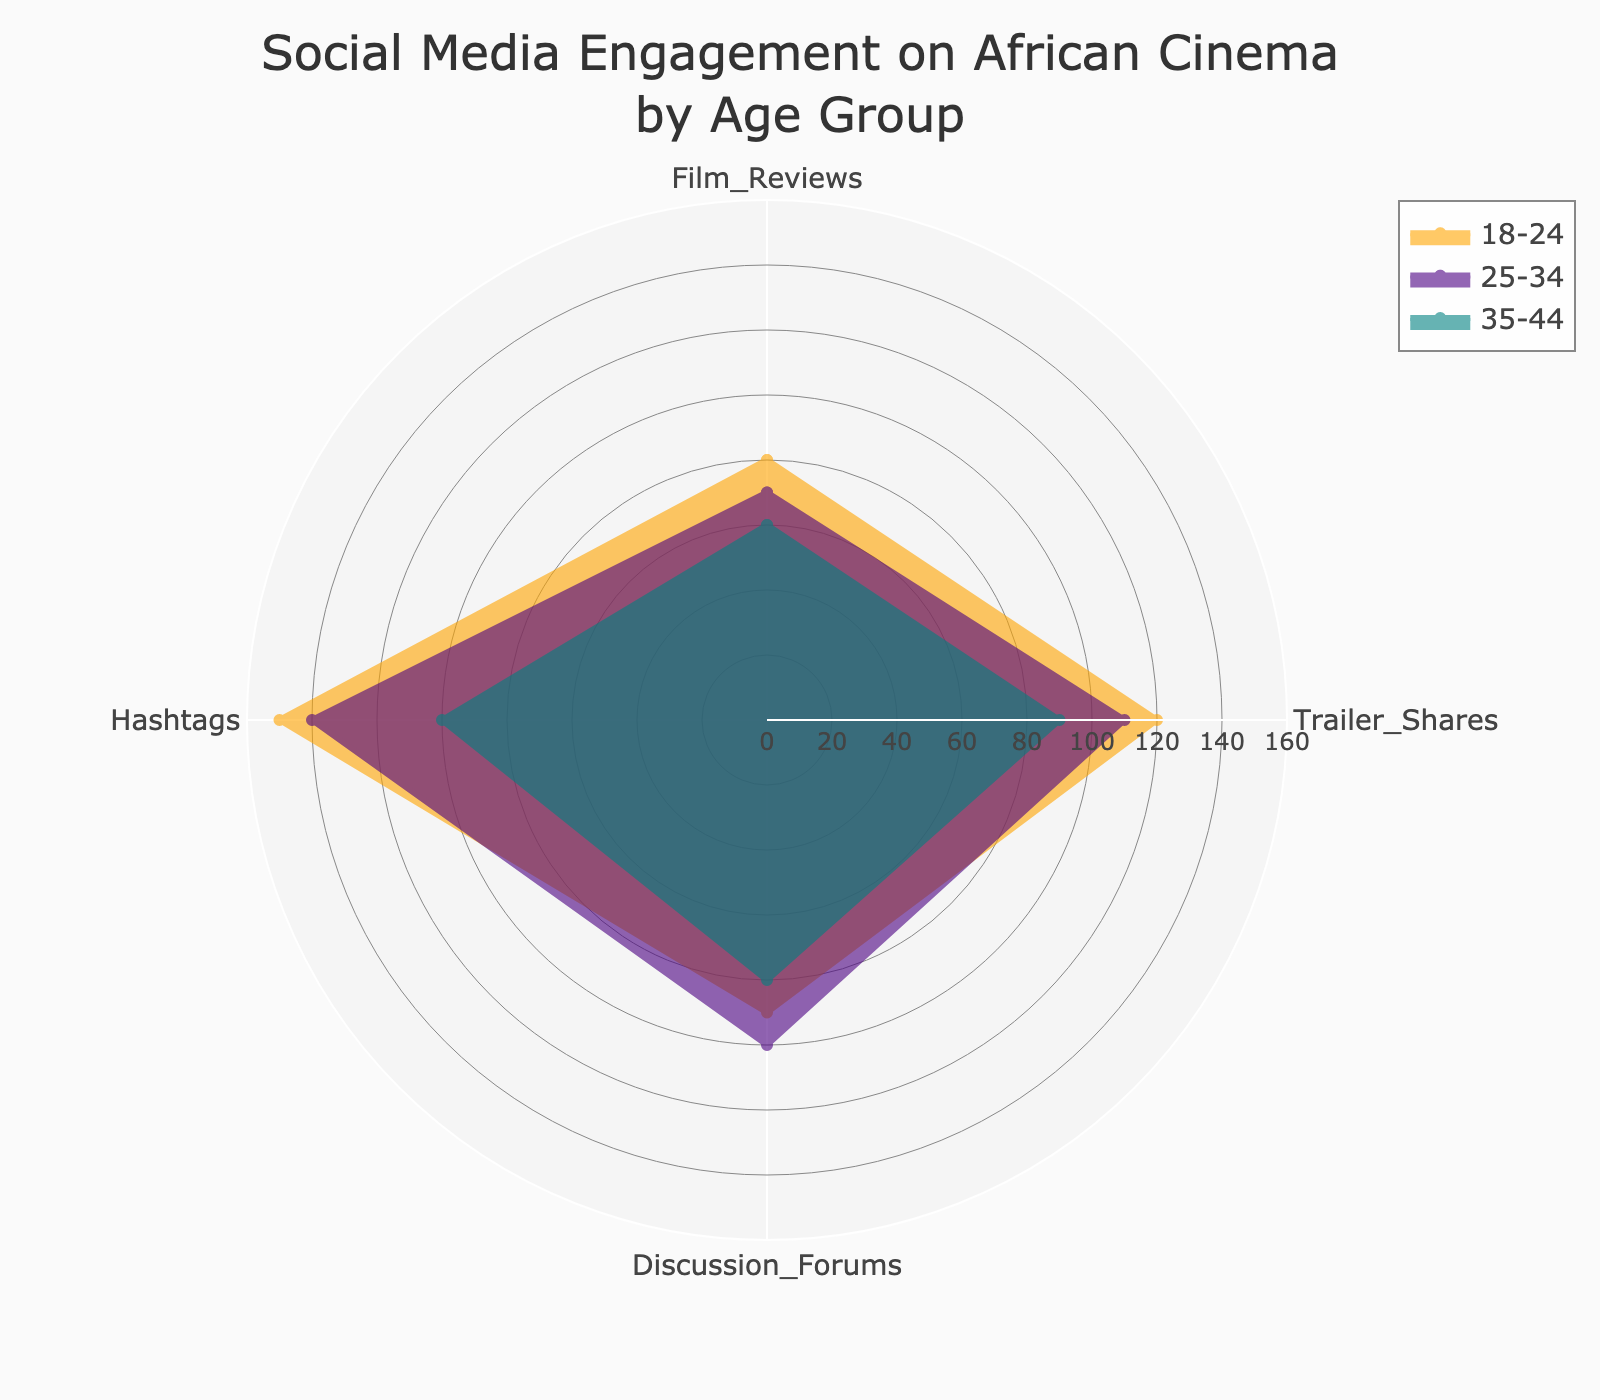What is the highest value in the category 'Trailer Shares'? Look at the 'Trailer Shares' values across all age groups and identify the highest number, which is 120 for the 18-24 age group.
Answer: 120 What is the title of the radar chart? The title is usually placed at the top of the chart, so you can read the title directly: "Social Media Engagement on African Cinema by Age Group".
Answer: Social Media Engagement on African Cinema by Age Group Which age group has the lowest engagement in 'Hashtags'? Compare the 'Hashtags' values for each age group; the 45-54 age group has the lowest value at 70.
Answer: 45-54 What color represents the 25-34 age group in the chart? Check the color legend associated with the 25-34 age group within the radar chart. The color for this group is #4B0082 (Indigo).
Answer: Indigo What is the average engagement in 'Discussion Forums' across the three age groups displayed? Add the 'Discussion Forums' values for the three age groups: 90 (18-24) + 100 (25-34) + 80 (35-44) = 270. Then divide by 3 to get the average: 270 / 3 = 90.
Answer: 90 Which age group shows the most balanced engagement across all categories? A balanced engagement would mean the smallest difference between the highest and lowest values within the age group. Compare the difference for each age group: 
- 18-24: 150 - 80 = 70 
- 25-34: 140 - 70 = 70 
- 35-44: 100 - 60 = 40
The 35-44 age group has the smallest difference, indicating the most balanced engagement.
Answer: 35-44 In which category do the 18-24 and 25-34 age groups have the same ranking? Compare both age groups across all categories to see if both rank similarly:
- 'Film Reviews': 80 (1st), 70 (2nd)
- 'Trailer Shares': 120 (1st), 110 (2nd)
- 'Discussion Forums': 90 (2nd), 100 (1st)
- 'Hashtags': 150 (1st), 140 (2nd)
Only in 'Discussion Forums' do these ranks overlap with 18-24 (2nd) and 25-34 (1st).
Answer: Discussion Forums How does the engagement in 'Film Reviews' for 45-54 compare to the other age groups? Check the value for 'Film Reviews' in the 45-54 age group (40) and compare it with other age groups:
- 18-24: 80
- 25-34: 70
- 35-44: 60
45-54 has the lowest engagement in 'Film Reviews' when compared to all other age groups listed.
Answer: Lowest What is the total social media engagement for the 35-44 age group across all categories? Sum up the engagement values for each category in the 35-44 age group: 
- 60 (Film Reviews) + 90 (Trailer Shares) + 80 (Discussion Forums) + 100 (Hashtags) = 330.
Answer: 330 